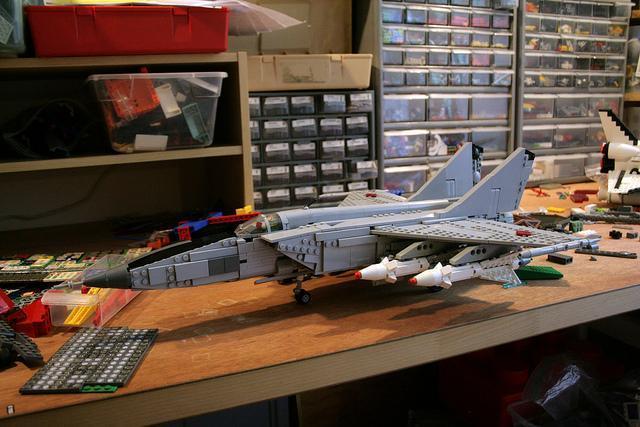Does the caption "The airplane is on the dining table." correctly depict the image?
Answer yes or no. Yes. Is the caption "The dining table is beneath the airplane." a true representation of the image?
Answer yes or no. Yes. 